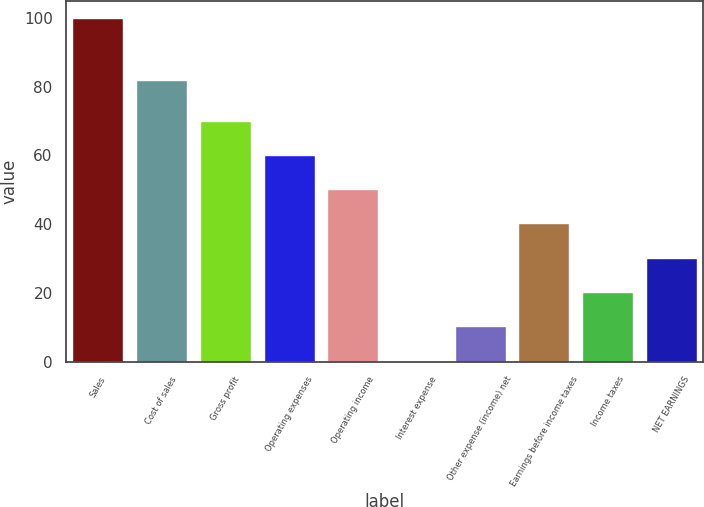Convert chart. <chart><loc_0><loc_0><loc_500><loc_500><bar_chart><fcel>Sales<fcel>Cost of sales<fcel>Gross profit<fcel>Operating expenses<fcel>Operating income<fcel>Interest expense<fcel>Other expense (income) net<fcel>Earnings before income taxes<fcel>Income taxes<fcel>NET EARNINGS<nl><fcel>100<fcel>81.9<fcel>70.09<fcel>60.12<fcel>50.15<fcel>0.3<fcel>10.27<fcel>40.18<fcel>20.24<fcel>30.21<nl></chart> 